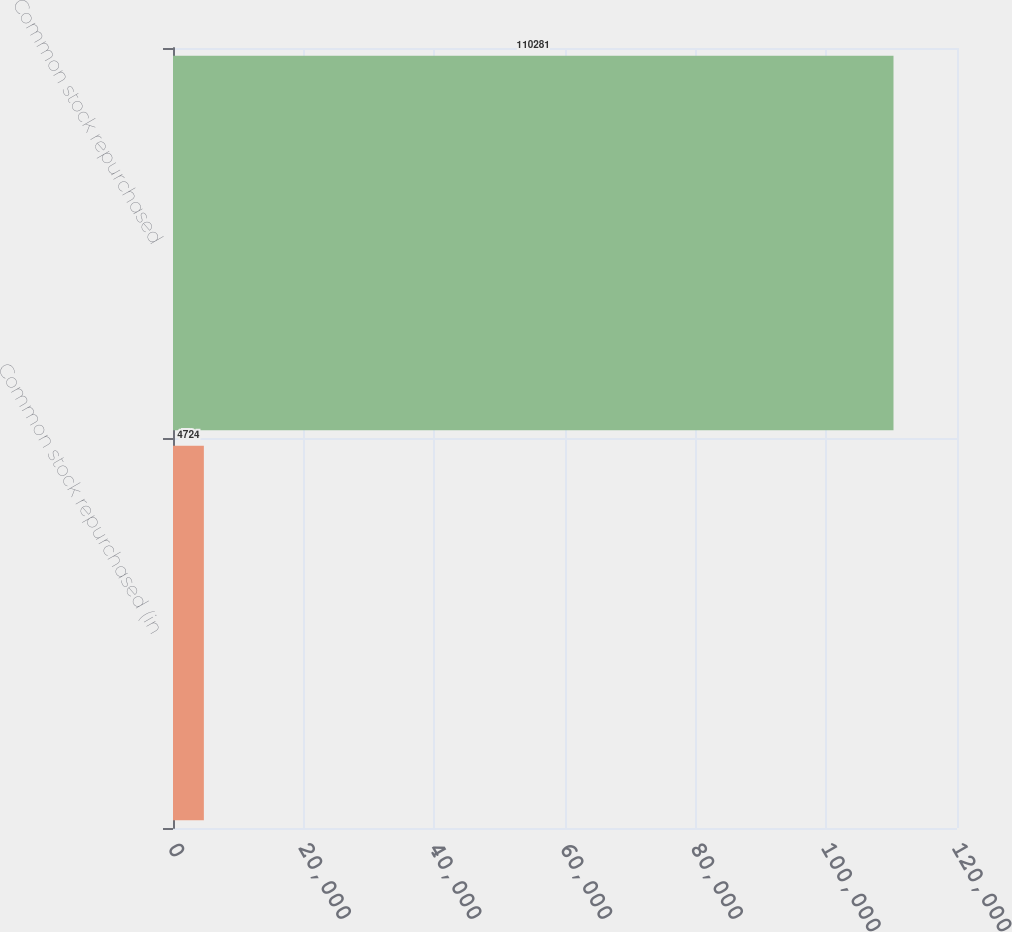Convert chart to OTSL. <chart><loc_0><loc_0><loc_500><loc_500><bar_chart><fcel>Common stock repurchased (in<fcel>Common stock repurchased<nl><fcel>4724<fcel>110281<nl></chart> 